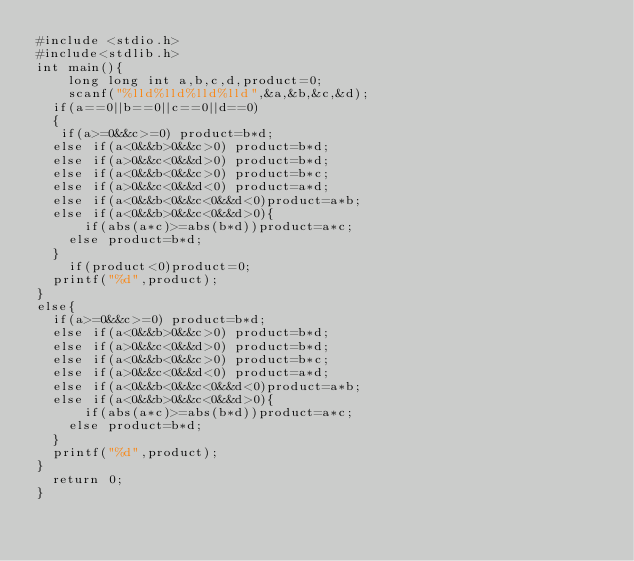Convert code to text. <code><loc_0><loc_0><loc_500><loc_500><_C_>#include <stdio.h>
#include<stdlib.h>
int main(){
    long long int a,b,c,d,product=0;
    scanf("%lld%lld%lld%lld",&a,&b,&c,&d);
  if(a==0||b==0||c==0||d==0)
  {
   if(a>=0&&c>=0) product=b*d;
  else if(a<0&&b>0&&c>0) product=b*d;
  else if(a>0&&c<0&&d>0) product=b*d;
  else if(a<0&&b<0&&c>0) product=b*c;
  else if(a>0&&c<0&&d<0) product=a*d;
  else if(a<0&&b<0&&c<0&&d<0)product=a*b;
  else if(a<0&&b>0&&c<0&&d>0){
      if(abs(a*c)>=abs(b*d))product=a*c;
    else product=b*d;
  }
    if(product<0)product=0;
  printf("%d",product);
}
else{
  if(a>=0&&c>=0) product=b*d;
  else if(a<0&&b>0&&c>0) product=b*d;
  else if(a>0&&c<0&&d>0) product=b*d;
  else if(a<0&&b<0&&c>0) product=b*c;
  else if(a>0&&c<0&&d<0) product=a*d;
  else if(a<0&&b<0&&c<0&&d<0)product=a*b;
  else if(a<0&&b>0&&c<0&&d>0){
      if(abs(a*c)>=abs(b*d))product=a*c;
    else product=b*d;
  }
  printf("%d",product);
}
  return 0;
}</code> 